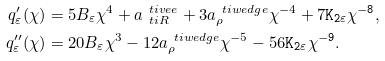Convert formula to latex. <formula><loc_0><loc_0><loc_500><loc_500>q _ { \varepsilon } ^ { \prime } ( \chi ) & = 5 B _ { \varepsilon } \chi ^ { 4 } + a _ { \ t i R } ^ { \ t i v e e } + 3 a _ { \rho } ^ { \ t i w e d g e } \chi ^ { - 4 } + 7 \tt K _ { 2 \varepsilon } \chi ^ { - 8 } , \\ q _ { \varepsilon } ^ { \prime \prime } ( \chi ) & = 2 0 B _ { \varepsilon } \chi ^ { 3 } - 1 2 a _ { \rho } ^ { \ t i w e d g e } \chi ^ { - 5 } - 5 6 \tt K _ { 2 \varepsilon } \chi ^ { - 9 } .</formula> 